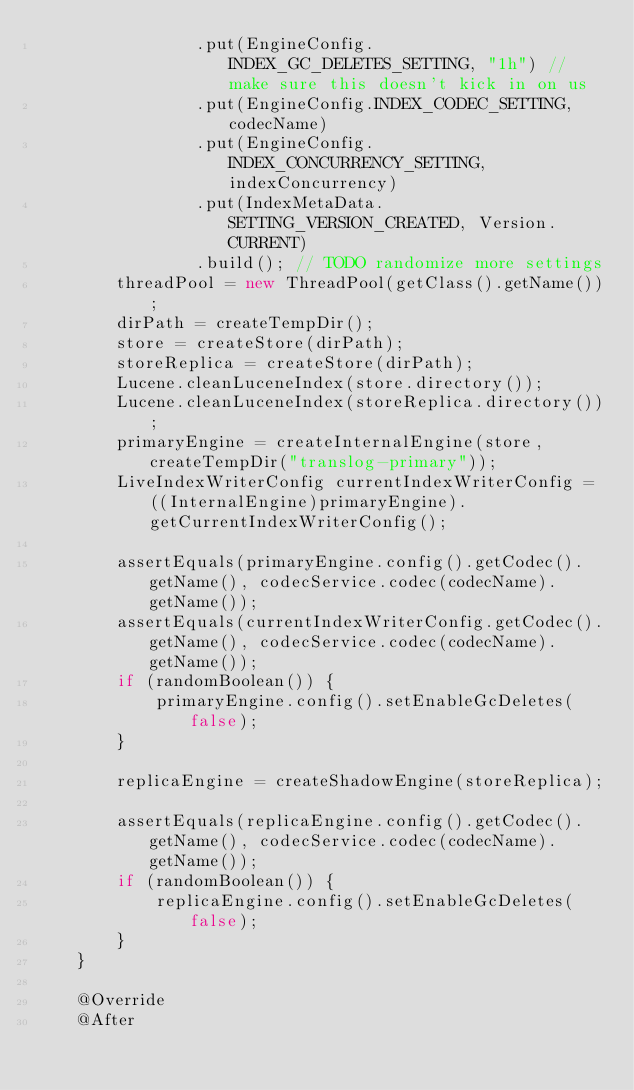Convert code to text. <code><loc_0><loc_0><loc_500><loc_500><_Java_>                .put(EngineConfig.INDEX_GC_DELETES_SETTING, "1h") // make sure this doesn't kick in on us
                .put(EngineConfig.INDEX_CODEC_SETTING, codecName)
                .put(EngineConfig.INDEX_CONCURRENCY_SETTING, indexConcurrency)
                .put(IndexMetaData.SETTING_VERSION_CREATED, Version.CURRENT)
                .build(); // TODO randomize more settings
        threadPool = new ThreadPool(getClass().getName());
        dirPath = createTempDir();
        store = createStore(dirPath);
        storeReplica = createStore(dirPath);
        Lucene.cleanLuceneIndex(store.directory());
        Lucene.cleanLuceneIndex(storeReplica.directory());
        primaryEngine = createInternalEngine(store, createTempDir("translog-primary"));
        LiveIndexWriterConfig currentIndexWriterConfig = ((InternalEngine)primaryEngine).getCurrentIndexWriterConfig();

        assertEquals(primaryEngine.config().getCodec().getName(), codecService.codec(codecName).getName());
        assertEquals(currentIndexWriterConfig.getCodec().getName(), codecService.codec(codecName).getName());
        if (randomBoolean()) {
            primaryEngine.config().setEnableGcDeletes(false);
        }

        replicaEngine = createShadowEngine(storeReplica);

        assertEquals(replicaEngine.config().getCodec().getName(), codecService.codec(codecName).getName());
        if (randomBoolean()) {
            replicaEngine.config().setEnableGcDeletes(false);
        }
    }

    @Override
    @After</code> 